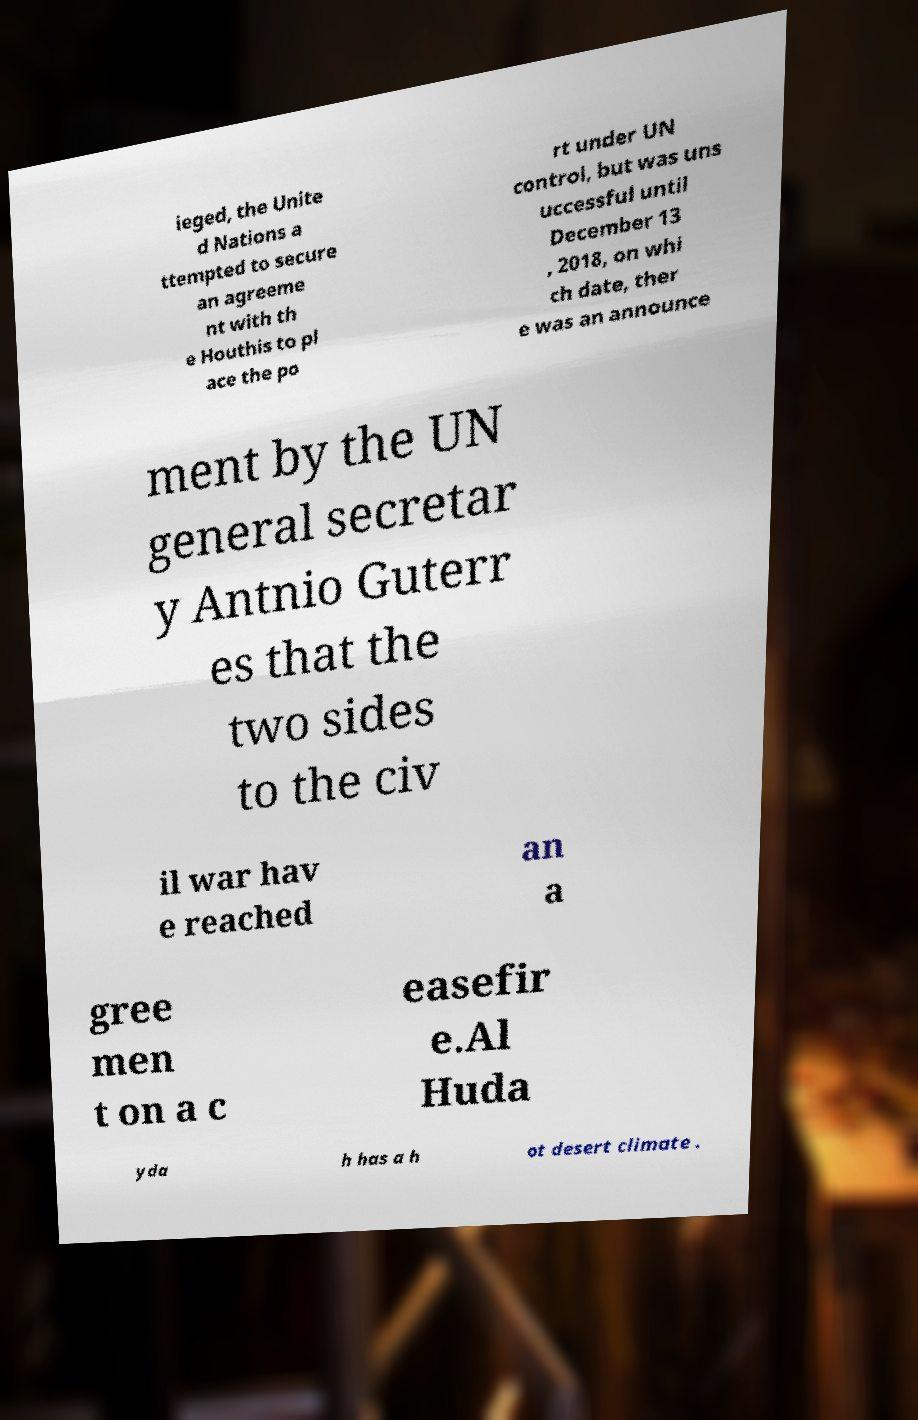There's text embedded in this image that I need extracted. Can you transcribe it verbatim? ieged, the Unite d Nations a ttempted to secure an agreeme nt with th e Houthis to pl ace the po rt under UN control, but was uns uccessful until December 13 , 2018, on whi ch date, ther e was an announce ment by the UN general secretar y Antnio Guterr es that the two sides to the civ il war hav e reached an a gree men t on a c easefir e.Al Huda yda h has a h ot desert climate . 